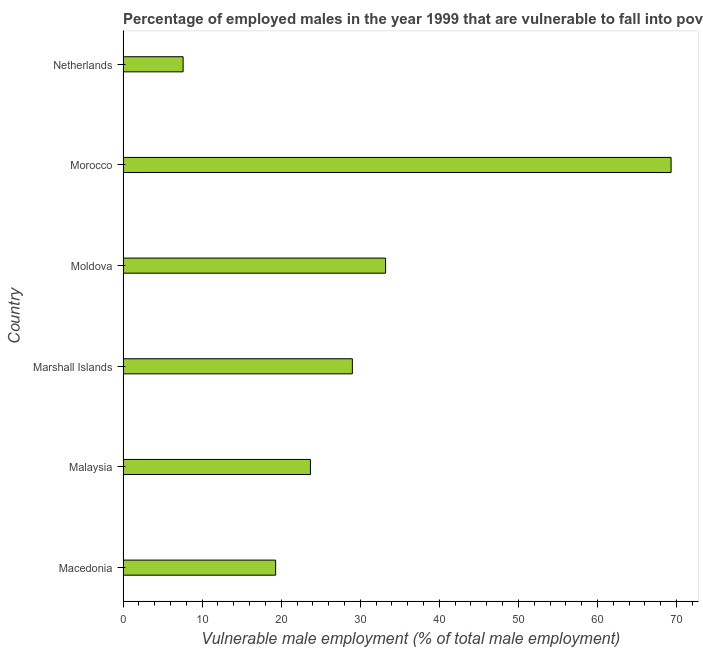Does the graph contain grids?
Your response must be concise. No. What is the title of the graph?
Ensure brevity in your answer.  Percentage of employed males in the year 1999 that are vulnerable to fall into poverty. What is the label or title of the X-axis?
Your answer should be very brief. Vulnerable male employment (% of total male employment). What is the label or title of the Y-axis?
Your answer should be very brief. Country. What is the percentage of employed males who are vulnerable to fall into poverty in Malaysia?
Make the answer very short. 23.7. Across all countries, what is the maximum percentage of employed males who are vulnerable to fall into poverty?
Provide a succinct answer. 69.3. Across all countries, what is the minimum percentage of employed males who are vulnerable to fall into poverty?
Your answer should be compact. 7.6. In which country was the percentage of employed males who are vulnerable to fall into poverty maximum?
Make the answer very short. Morocco. In which country was the percentage of employed males who are vulnerable to fall into poverty minimum?
Offer a terse response. Netherlands. What is the sum of the percentage of employed males who are vulnerable to fall into poverty?
Give a very brief answer. 182.1. What is the average percentage of employed males who are vulnerable to fall into poverty per country?
Keep it short and to the point. 30.35. What is the median percentage of employed males who are vulnerable to fall into poverty?
Provide a succinct answer. 26.35. In how many countries, is the percentage of employed males who are vulnerable to fall into poverty greater than 54 %?
Give a very brief answer. 1. What is the ratio of the percentage of employed males who are vulnerable to fall into poverty in Macedonia to that in Malaysia?
Offer a very short reply. 0.81. Is the percentage of employed males who are vulnerable to fall into poverty in Macedonia less than that in Netherlands?
Your answer should be compact. No. What is the difference between the highest and the second highest percentage of employed males who are vulnerable to fall into poverty?
Provide a succinct answer. 36.1. What is the difference between the highest and the lowest percentage of employed males who are vulnerable to fall into poverty?
Provide a succinct answer. 61.7. In how many countries, is the percentage of employed males who are vulnerable to fall into poverty greater than the average percentage of employed males who are vulnerable to fall into poverty taken over all countries?
Offer a terse response. 2. How many bars are there?
Ensure brevity in your answer.  6. What is the difference between two consecutive major ticks on the X-axis?
Your response must be concise. 10. Are the values on the major ticks of X-axis written in scientific E-notation?
Keep it short and to the point. No. What is the Vulnerable male employment (% of total male employment) of Macedonia?
Your answer should be compact. 19.3. What is the Vulnerable male employment (% of total male employment) in Malaysia?
Provide a succinct answer. 23.7. What is the Vulnerable male employment (% of total male employment) of Moldova?
Provide a short and direct response. 33.2. What is the Vulnerable male employment (% of total male employment) in Morocco?
Offer a terse response. 69.3. What is the Vulnerable male employment (% of total male employment) of Netherlands?
Ensure brevity in your answer.  7.6. What is the difference between the Vulnerable male employment (% of total male employment) in Macedonia and Marshall Islands?
Your answer should be very brief. -9.7. What is the difference between the Vulnerable male employment (% of total male employment) in Macedonia and Morocco?
Offer a terse response. -50. What is the difference between the Vulnerable male employment (% of total male employment) in Malaysia and Marshall Islands?
Your response must be concise. -5.3. What is the difference between the Vulnerable male employment (% of total male employment) in Malaysia and Morocco?
Your answer should be compact. -45.6. What is the difference between the Vulnerable male employment (% of total male employment) in Malaysia and Netherlands?
Your response must be concise. 16.1. What is the difference between the Vulnerable male employment (% of total male employment) in Marshall Islands and Morocco?
Make the answer very short. -40.3. What is the difference between the Vulnerable male employment (% of total male employment) in Marshall Islands and Netherlands?
Ensure brevity in your answer.  21.4. What is the difference between the Vulnerable male employment (% of total male employment) in Moldova and Morocco?
Your answer should be compact. -36.1. What is the difference between the Vulnerable male employment (% of total male employment) in Moldova and Netherlands?
Your answer should be compact. 25.6. What is the difference between the Vulnerable male employment (% of total male employment) in Morocco and Netherlands?
Your response must be concise. 61.7. What is the ratio of the Vulnerable male employment (% of total male employment) in Macedonia to that in Malaysia?
Offer a terse response. 0.81. What is the ratio of the Vulnerable male employment (% of total male employment) in Macedonia to that in Marshall Islands?
Offer a very short reply. 0.67. What is the ratio of the Vulnerable male employment (% of total male employment) in Macedonia to that in Moldova?
Offer a terse response. 0.58. What is the ratio of the Vulnerable male employment (% of total male employment) in Macedonia to that in Morocco?
Ensure brevity in your answer.  0.28. What is the ratio of the Vulnerable male employment (% of total male employment) in Macedonia to that in Netherlands?
Your response must be concise. 2.54. What is the ratio of the Vulnerable male employment (% of total male employment) in Malaysia to that in Marshall Islands?
Your response must be concise. 0.82. What is the ratio of the Vulnerable male employment (% of total male employment) in Malaysia to that in Moldova?
Offer a very short reply. 0.71. What is the ratio of the Vulnerable male employment (% of total male employment) in Malaysia to that in Morocco?
Ensure brevity in your answer.  0.34. What is the ratio of the Vulnerable male employment (% of total male employment) in Malaysia to that in Netherlands?
Your answer should be very brief. 3.12. What is the ratio of the Vulnerable male employment (% of total male employment) in Marshall Islands to that in Moldova?
Offer a very short reply. 0.87. What is the ratio of the Vulnerable male employment (% of total male employment) in Marshall Islands to that in Morocco?
Provide a short and direct response. 0.42. What is the ratio of the Vulnerable male employment (% of total male employment) in Marshall Islands to that in Netherlands?
Your answer should be very brief. 3.82. What is the ratio of the Vulnerable male employment (% of total male employment) in Moldova to that in Morocco?
Make the answer very short. 0.48. What is the ratio of the Vulnerable male employment (% of total male employment) in Moldova to that in Netherlands?
Your response must be concise. 4.37. What is the ratio of the Vulnerable male employment (% of total male employment) in Morocco to that in Netherlands?
Offer a terse response. 9.12. 